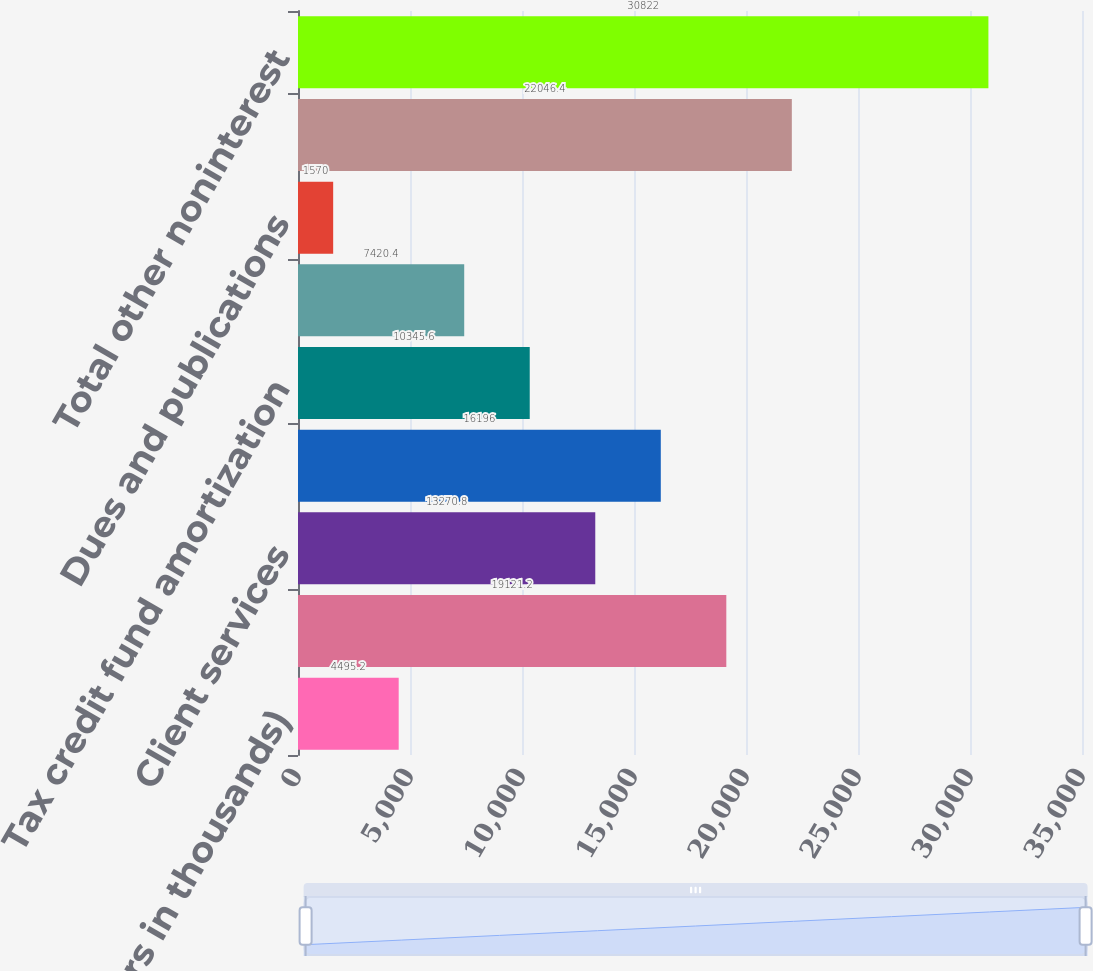Convert chart. <chart><loc_0><loc_0><loc_500><loc_500><bar_chart><fcel>(Dollars in thousands)<fcel>Telephone<fcel>Client services<fcel>Data processing services<fcel>Tax credit fund amortization<fcel>Postage and supplies<fcel>Dues and publications<fcel>Other<fcel>Total other noninterest<nl><fcel>4495.2<fcel>19121.2<fcel>13270.8<fcel>16196<fcel>10345.6<fcel>7420.4<fcel>1570<fcel>22046.4<fcel>30822<nl></chart> 